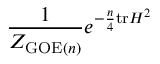Convert formula to latex. <formula><loc_0><loc_0><loc_500><loc_500>{ \frac { 1 } { Z _ { { G O E } ( n ) } } } e ^ { - { \frac { n } { 4 } } t r H ^ { 2 } }</formula> 